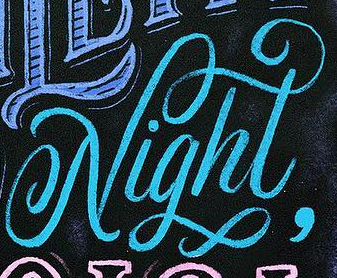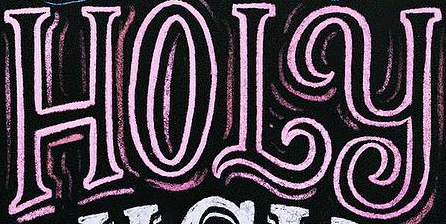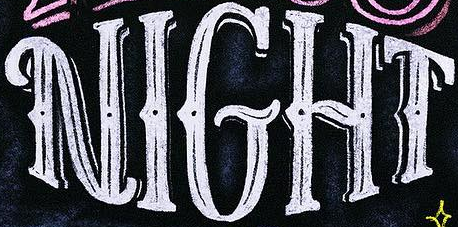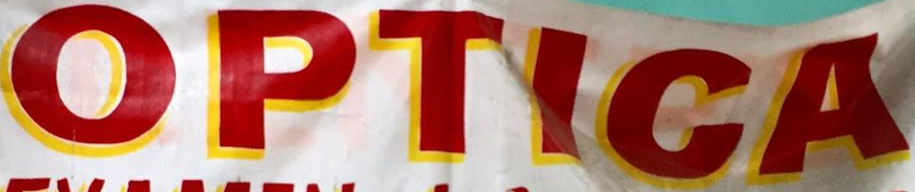Read the text from these images in sequence, separated by a semicolon. Night; HOLY; NIGHT; OPTICA 